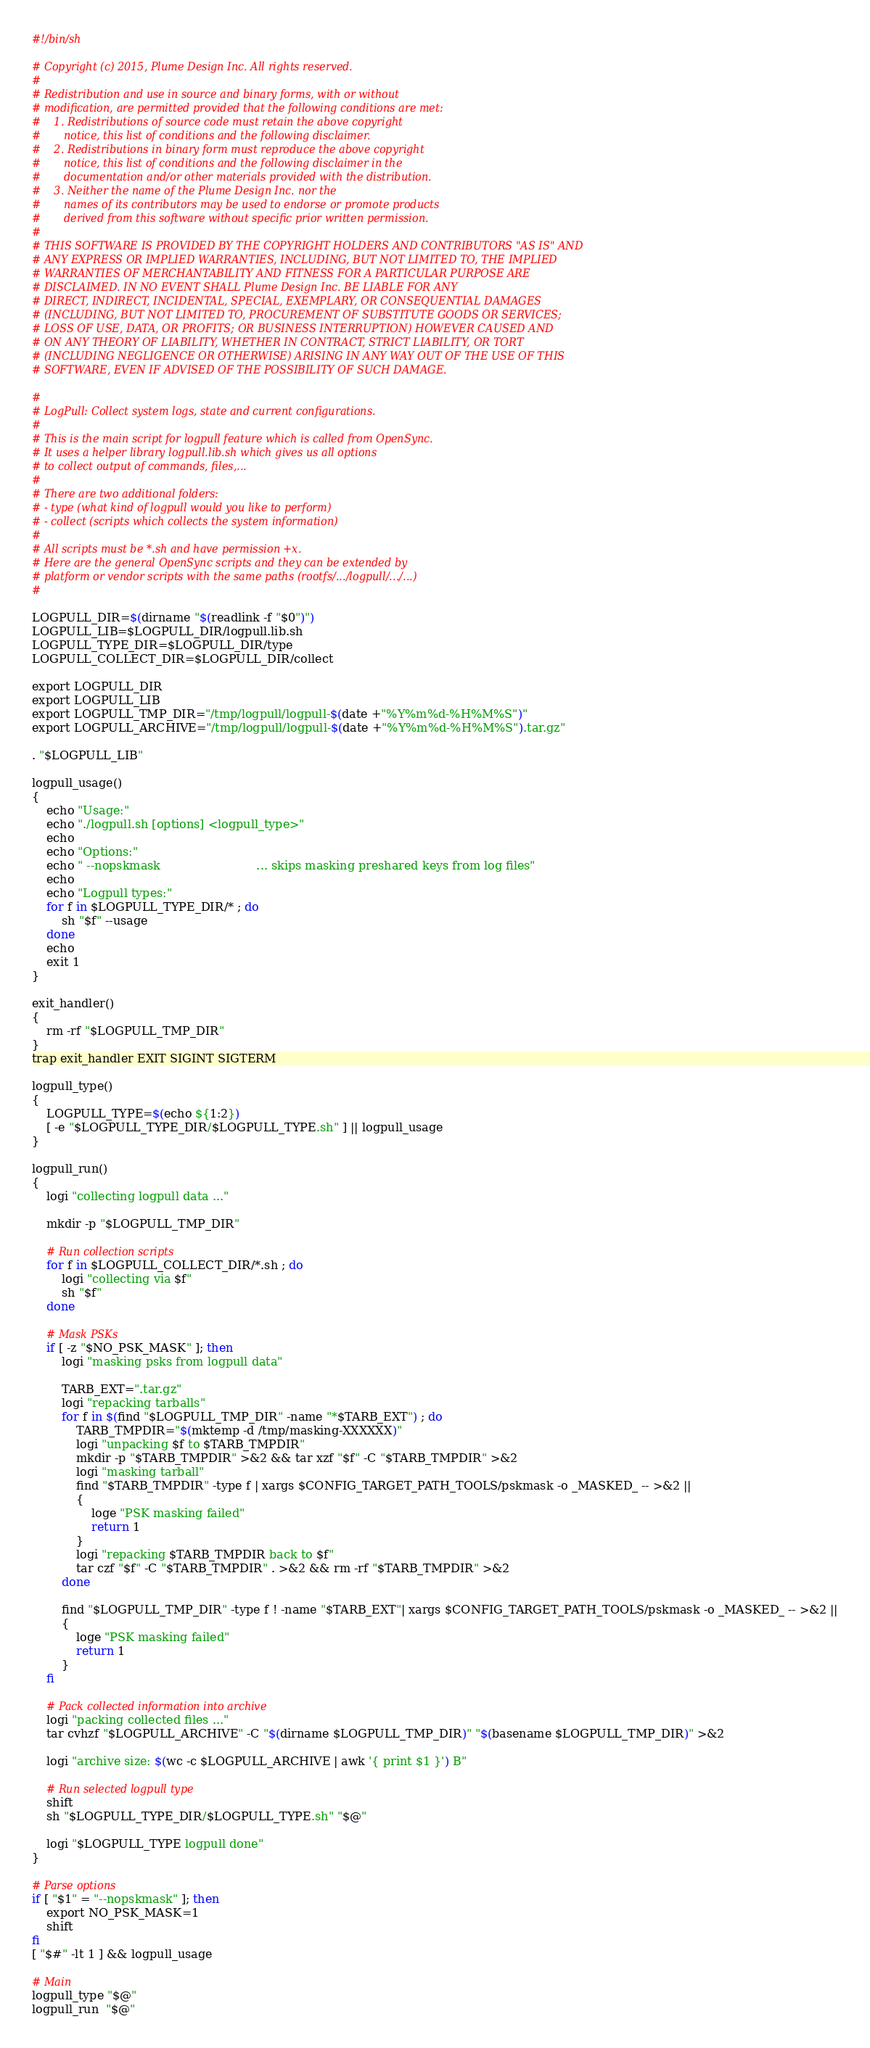Convert code to text. <code><loc_0><loc_0><loc_500><loc_500><_Bash_>#!/bin/sh

# Copyright (c) 2015, Plume Design Inc. All rights reserved.
# 
# Redistribution and use in source and binary forms, with or without
# modification, are permitted provided that the following conditions are met:
#    1. Redistributions of source code must retain the above copyright
#       notice, this list of conditions and the following disclaimer.
#    2. Redistributions in binary form must reproduce the above copyright
#       notice, this list of conditions and the following disclaimer in the
#       documentation and/or other materials provided with the distribution.
#    3. Neither the name of the Plume Design Inc. nor the
#       names of its contributors may be used to endorse or promote products
#       derived from this software without specific prior written permission.
# 
# THIS SOFTWARE IS PROVIDED BY THE COPYRIGHT HOLDERS AND CONTRIBUTORS "AS IS" AND
# ANY EXPRESS OR IMPLIED WARRANTIES, INCLUDING, BUT NOT LIMITED TO, THE IMPLIED
# WARRANTIES OF MERCHANTABILITY AND FITNESS FOR A PARTICULAR PURPOSE ARE
# DISCLAIMED. IN NO EVENT SHALL Plume Design Inc. BE LIABLE FOR ANY
# DIRECT, INDIRECT, INCIDENTAL, SPECIAL, EXEMPLARY, OR CONSEQUENTIAL DAMAGES
# (INCLUDING, BUT NOT LIMITED TO, PROCUREMENT OF SUBSTITUTE GOODS OR SERVICES;
# LOSS OF USE, DATA, OR PROFITS; OR BUSINESS INTERRUPTION) HOWEVER CAUSED AND
# ON ANY THEORY OF LIABILITY, WHETHER IN CONTRACT, STRICT LIABILITY, OR TORT
# (INCLUDING NEGLIGENCE OR OTHERWISE) ARISING IN ANY WAY OUT OF THE USE OF THIS
# SOFTWARE, EVEN IF ADVISED OF THE POSSIBILITY OF SUCH DAMAGE.

#
# LogPull: Collect system logs, state and current configurations.
#
# This is the main script for logpull feature which is called from OpenSync.
# It uses a helper library logpull.lib.sh which gives us all options
# to collect output of commands, files,...
#
# There are two additional folders:
# - type (what kind of logpull would you like to perform)
# - collect (scripts which collects the system information)
#
# All scripts must be *.sh and have permission +x.
# Here are the general OpenSync scripts and they can be extended by
# platform or vendor scripts with the same paths (rootfs/.../logpull/.../...)
#

LOGPULL_DIR=$(dirname "$(readlink -f "$0")")
LOGPULL_LIB=$LOGPULL_DIR/logpull.lib.sh
LOGPULL_TYPE_DIR=$LOGPULL_DIR/type
LOGPULL_COLLECT_DIR=$LOGPULL_DIR/collect

export LOGPULL_DIR
export LOGPULL_LIB
export LOGPULL_TMP_DIR="/tmp/logpull/logpull-$(date +"%Y%m%d-%H%M%S")"
export LOGPULL_ARCHIVE="/tmp/logpull/logpull-$(date +"%Y%m%d-%H%M%S").tar.gz"

. "$LOGPULL_LIB"

logpull_usage()
{
    echo "Usage:"
    echo "./logpull.sh [options] <logpull_type>"
    echo
    echo "Options:"
    echo " --nopskmask                          ... skips masking preshared keys from log files"
    echo 
    echo "Logpull types:"
    for f in $LOGPULL_TYPE_DIR/* ; do
        sh "$f" --usage
    done
    echo
    exit 1
}

exit_handler()
{
    rm -rf "$LOGPULL_TMP_DIR"
}
trap exit_handler EXIT SIGINT SIGTERM

logpull_type()
{
    LOGPULL_TYPE=$(echo ${1:2})
    [ -e "$LOGPULL_TYPE_DIR/$LOGPULL_TYPE.sh" ] || logpull_usage
}

logpull_run()
{
    logi "collecting logpull data ..."

    mkdir -p "$LOGPULL_TMP_DIR"

    # Run collection scripts
    for f in $LOGPULL_COLLECT_DIR/*.sh ; do
        logi "collecting via $f"
        sh "$f"
    done

    # Mask PSKs
    if [ -z "$NO_PSK_MASK" ]; then
        logi "masking psks from logpull data"

        TARB_EXT=".tar.gz"
        logi "repacking tarballs"
        for f in $(find "$LOGPULL_TMP_DIR" -name "*$TARB_EXT") ; do
            TARB_TMPDIR="$(mktemp -d /tmp/masking-XXXXXX)"
            logi "unpacking $f to $TARB_TMPDIR"
            mkdir -p "$TARB_TMPDIR" >&2 && tar xzf "$f" -C "$TARB_TMPDIR" >&2
            logi "masking tarball"
            find "$TARB_TMPDIR" -type f | xargs $CONFIG_TARGET_PATH_TOOLS/pskmask -o _MASKED_ -- >&2 ||
            {
                loge "PSK masking failed"
                return 1
            }
            logi "repacking $TARB_TMPDIR back to $f"
            tar czf "$f" -C "$TARB_TMPDIR" . >&2 && rm -rf "$TARB_TMPDIR" >&2
        done

        find "$LOGPULL_TMP_DIR" -type f ! -name "$TARB_EXT"| xargs $CONFIG_TARGET_PATH_TOOLS/pskmask -o _MASKED_ -- >&2 ||
        {
            loge "PSK masking failed"
            return 1
        }
    fi

    # Pack collected information into archive
    logi "packing collected files ..."
    tar cvhzf "$LOGPULL_ARCHIVE" -C "$(dirname $LOGPULL_TMP_DIR)" "$(basename $LOGPULL_TMP_DIR)" >&2

    logi "archive size: $(wc -c $LOGPULL_ARCHIVE | awk '{ print $1 }') B"

    # Run selected logpull type
    shift
    sh "$LOGPULL_TYPE_DIR/$LOGPULL_TYPE.sh" "$@"

    logi "$LOGPULL_TYPE logpull done"
}

# Parse options
if [ "$1" = "--nopskmask" ]; then
    export NO_PSK_MASK=1
    shift
fi
[ "$#" -lt 1 ] && logpull_usage

# Main
logpull_type "$@"
logpull_run  "$@"
</code> 